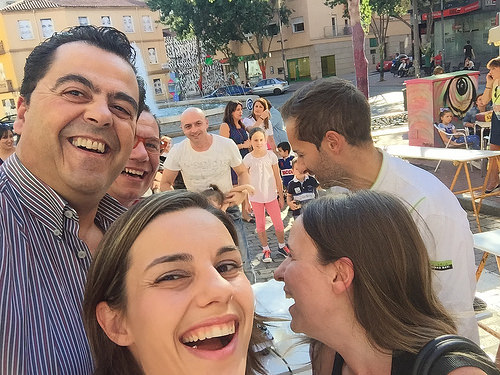<image>
Can you confirm if the shoe is on the person? No. The shoe is not positioned on the person. They may be near each other, but the shoe is not supported by or resting on top of the person. Where is the fountain in relation to the man? Is it to the left of the man? No. The fountain is not to the left of the man. From this viewpoint, they have a different horizontal relationship. Is there a car to the right of the building? No. The car is not to the right of the building. The horizontal positioning shows a different relationship. 